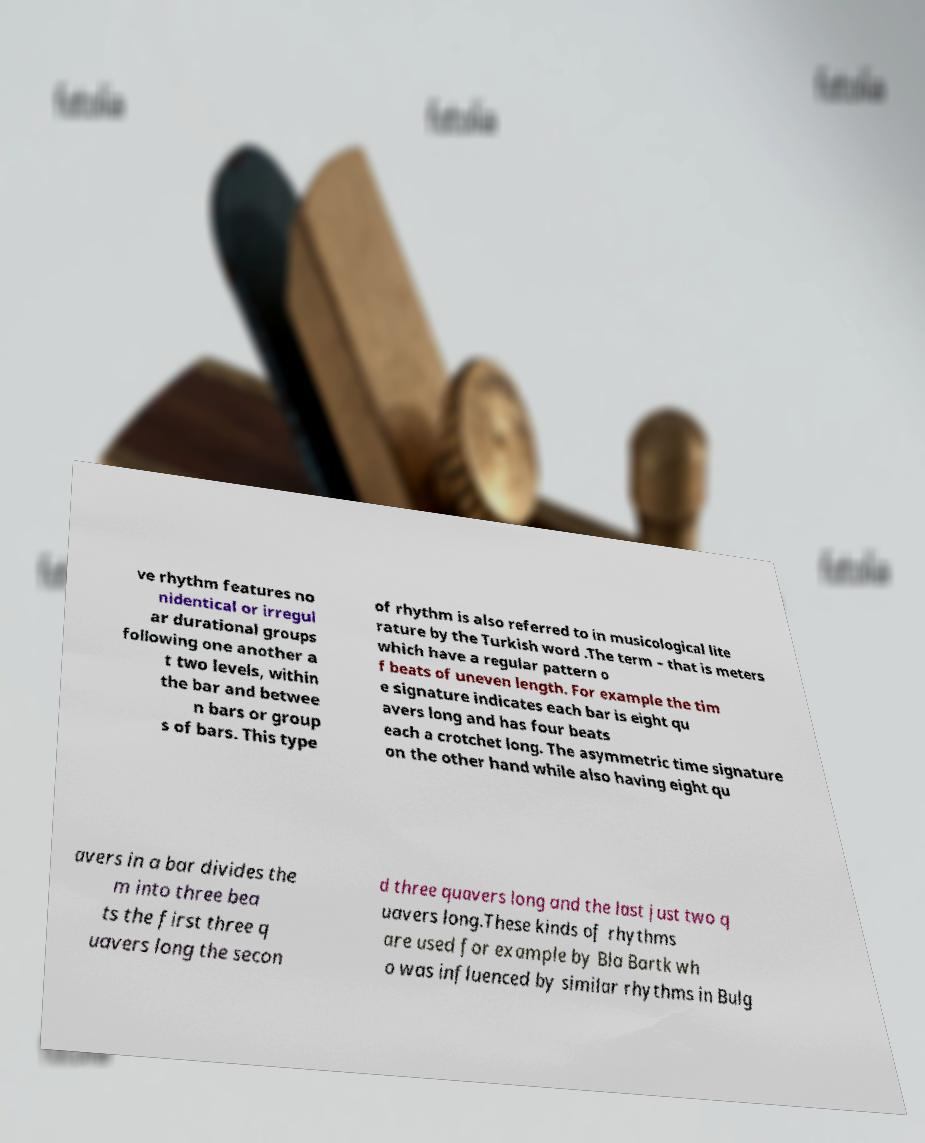What messages or text are displayed in this image? I need them in a readable, typed format. ve rhythm features no nidentical or irregul ar durational groups following one another a t two levels, within the bar and betwee n bars or group s of bars. This type of rhythm is also referred to in musicological lite rature by the Turkish word .The term – that is meters which have a regular pattern o f beats of uneven length. For example the tim e signature indicates each bar is eight qu avers long and has four beats each a crotchet long. The asymmetric time signature on the other hand while also having eight qu avers in a bar divides the m into three bea ts the first three q uavers long the secon d three quavers long and the last just two q uavers long.These kinds of rhythms are used for example by Bla Bartk wh o was influenced by similar rhythms in Bulg 